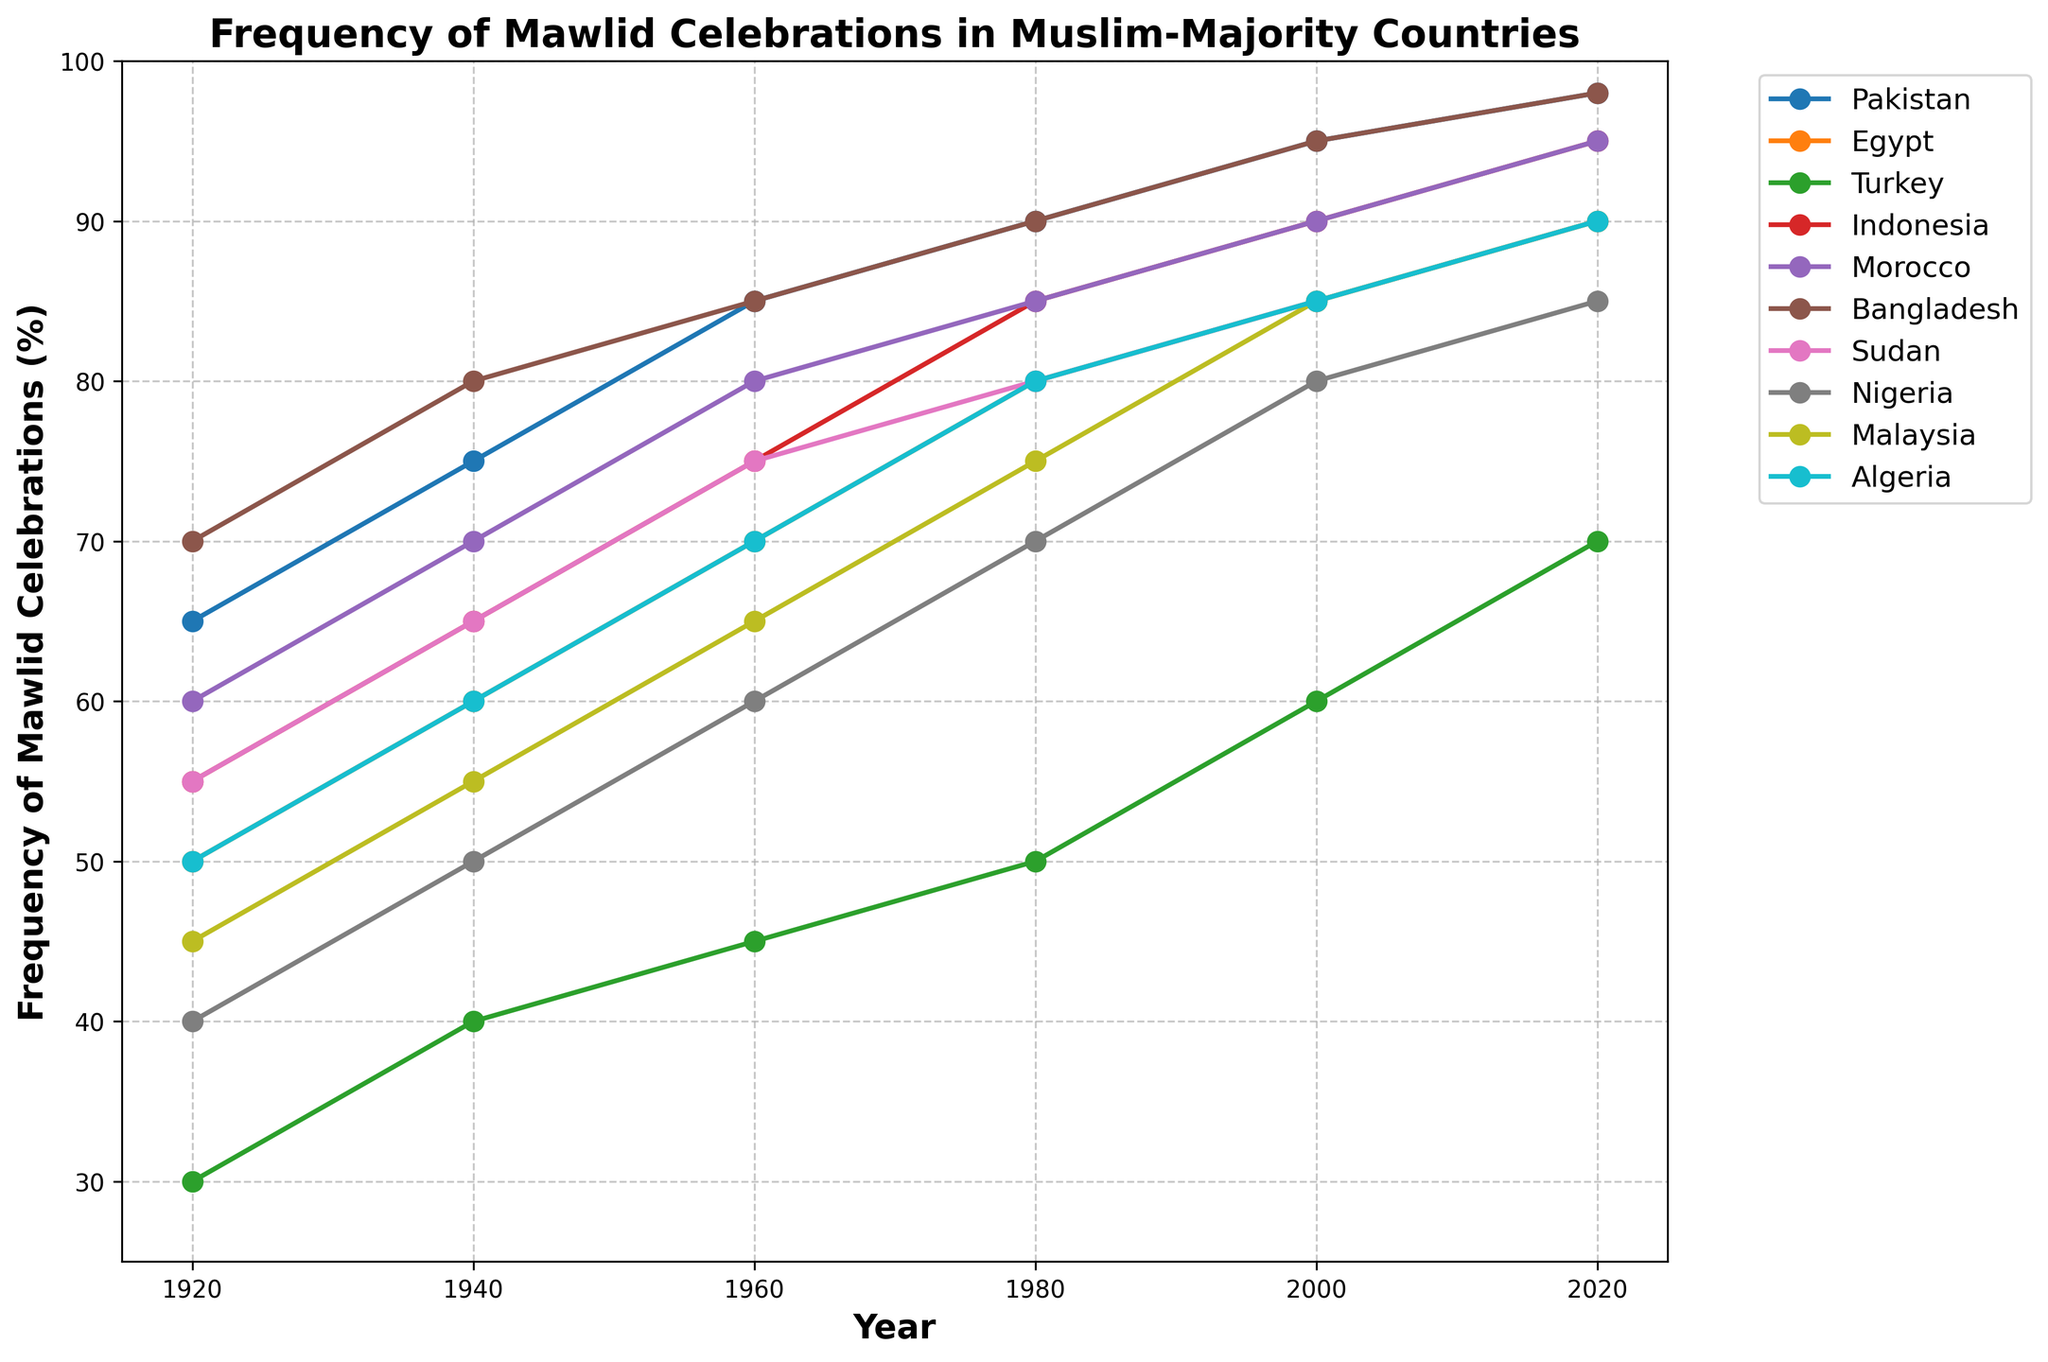Which country had the highest frequency of Mawlid celebrations in 2020? Look at the 2020 data points for all countries and identify the one with the highest percentage. Bangladesh and Pakistan both have 98%.
Answer: Bangladesh, Pakistan Which country experienced the greatest increase in the frequency of Mawlid celebrations from 1920 to 2020? Calculate the increase for each country by subtracting the 1920 value from the 2020 value and compare. Pakistan started at 65% in 1920 and reached 98% in 2020, a 33% increase, which is the highest.
Answer: Pakistan Which two countries had the same frequency of Mawlid celebrations in 1980? Identify the data points for 1980 and look for countries with identical percentages. Algeria and Sudan both had 80% in 1980.
Answer: Algeria, Sudan By how much did the frequency of Mawlid celebrations in Turkey increase between 1940 and 2000? Subtract Turkey's 1940 value (40%) from its 2000 value (60%). The increase is 20%.
Answer: 20% Which country showed the least variation in the frequency of Mawlid celebrations across the entire century? Compare the ranges (max-min values) for each country. Turkey's frequency ranged from 30% to 70%, an increase of 40%, which is the smallest variation among the countries.
Answer: Turkey What is the average frequency of Mawlid celebrations in Pakistan between 1920 and 2020? Sum the data points for Pakistan (65 + 75 + 85 + 90 + 95 + 98) and divide by the number of data points (6). The average is 508/6 = 84.67%.
Answer: 84.67% Which decade saw the most significant increase in Mawlid celebrations for Indonesia? Calculate the increases for each decade by observing the data points for Indonesia. The increase from 1970 (75%) to 1980 (85%) is the most significant, a 10% increase.
Answer: 1970-1980 In 2000, which countries had a frequency of Mawlid celebrations equal to or greater than 85%? Look at the 2000 data points for each country. Pakistan, Morocco, Indonesia, Bangladesh all had 90-95%.
Answer: Pakistan, Morocco, Indonesia, Bangladesh How many countries had at least a 30% increase in the frequency of Mawlid celebrations from 1920 to 2020? Calculate the difference between the 1920 and 2020 data points for each country and count those with at least a 30% increase. Six countries (Pakistan, Egypt, Morocco, Indonesia, Bangladesh, Sudan) had an increase of 30% or more.
Answer: 6 